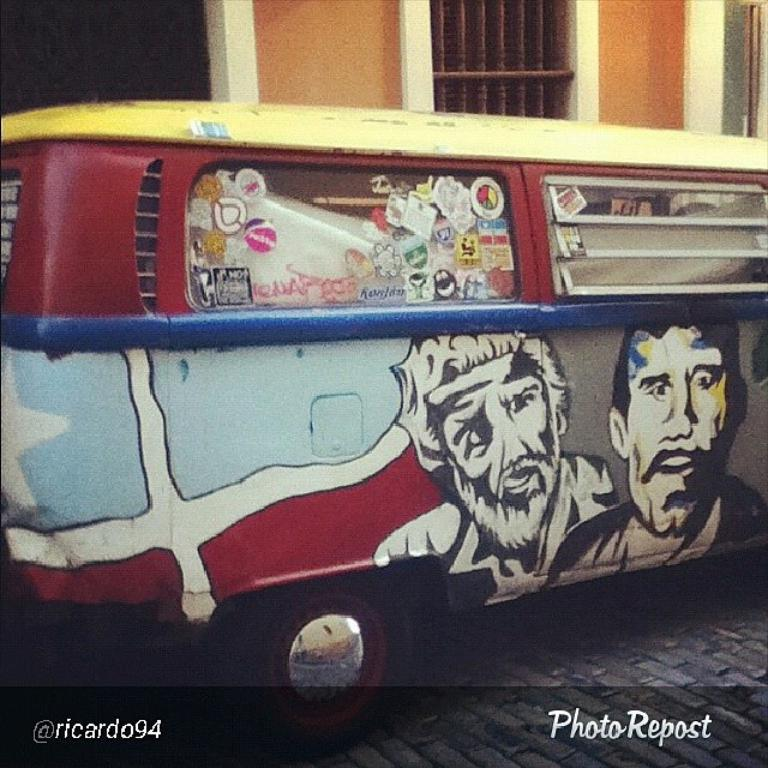What is the main subject in the center of the image? There is a van in the center of the image. What can be observed about the van's appearance? The van has paintings on it. What can be seen in the background of the image? There is a window and a wall in the background of the image. What type of surface is visible at the bottom of the image? The bottom of the image features pavement. Is there a vessel involved in a fight in the image? There is no vessel or fight present in the image. Is there a tent visible in the image? There is no tent present in the image. 